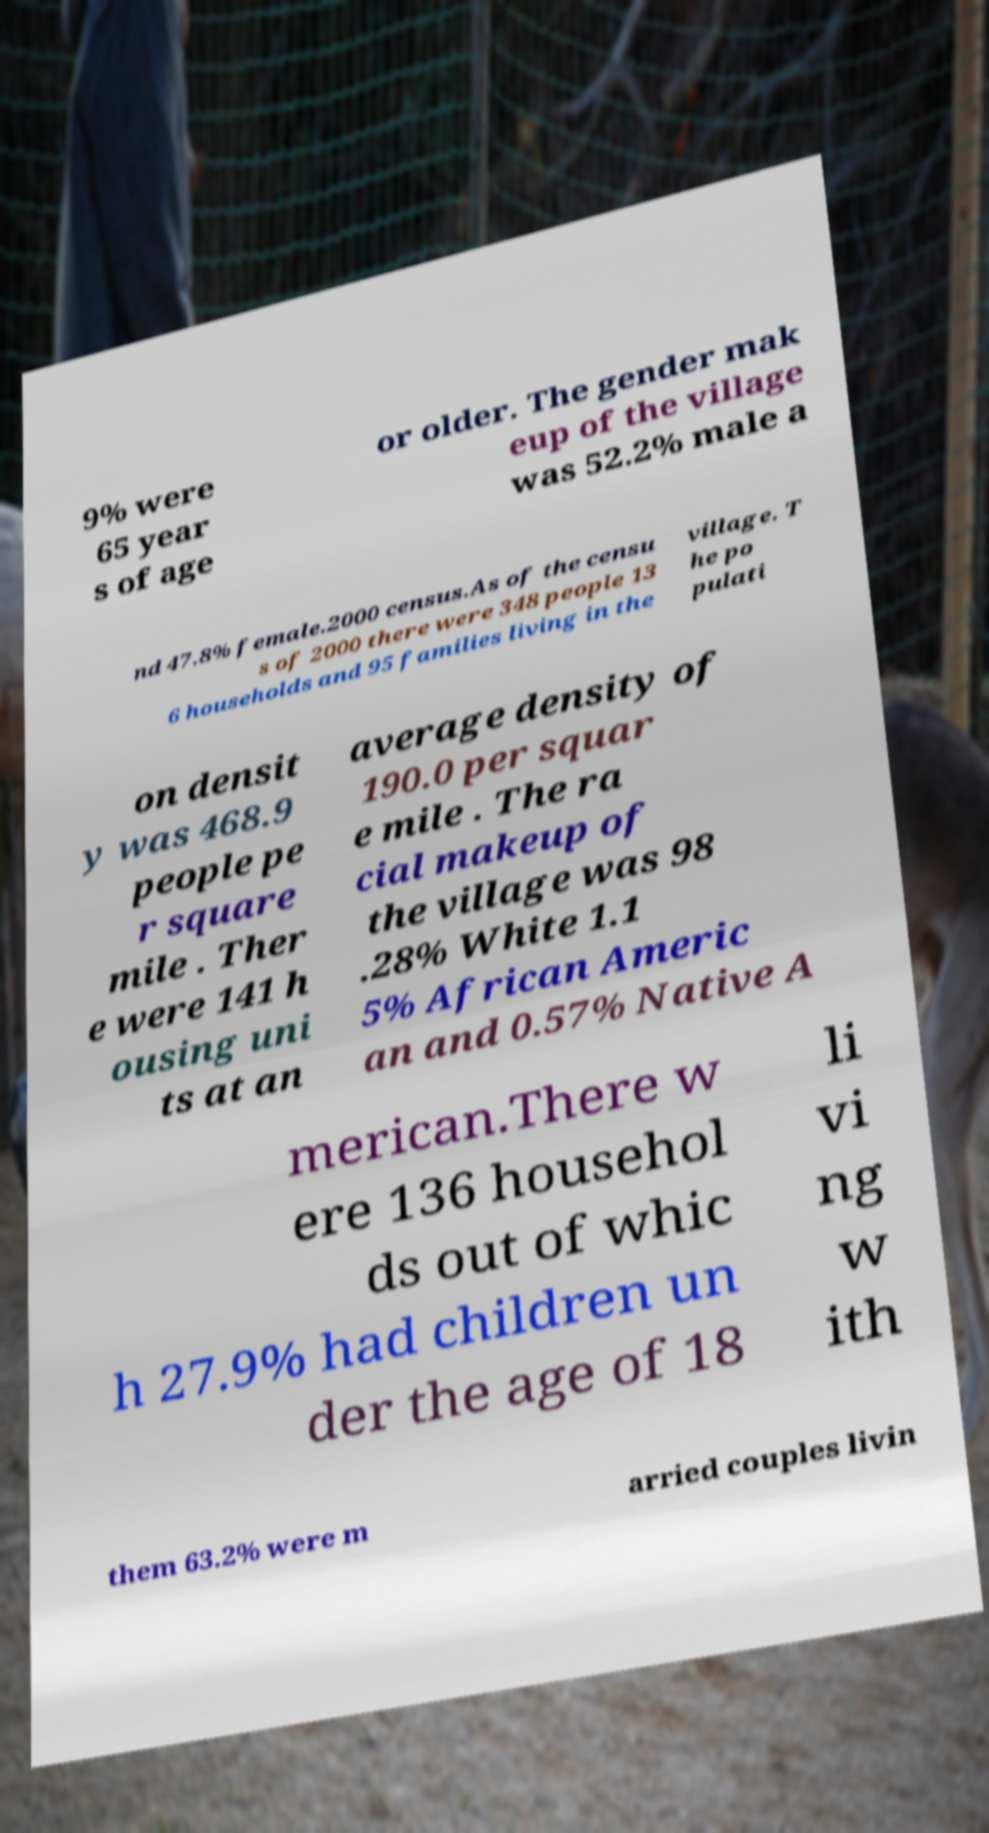Please identify and transcribe the text found in this image. 9% were 65 year s of age or older. The gender mak eup of the village was 52.2% male a nd 47.8% female.2000 census.As of the censu s of 2000 there were 348 people 13 6 households and 95 families living in the village. T he po pulati on densit y was 468.9 people pe r square mile . Ther e were 141 h ousing uni ts at an average density of 190.0 per squar e mile . The ra cial makeup of the village was 98 .28% White 1.1 5% African Americ an and 0.57% Native A merican.There w ere 136 househol ds out of whic h 27.9% had children un der the age of 18 li vi ng w ith them 63.2% were m arried couples livin 